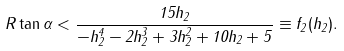<formula> <loc_0><loc_0><loc_500><loc_500>R \tan \alpha < \frac { 1 5 h _ { 2 } } { - h _ { 2 } ^ { 4 } - 2 h _ { 2 } ^ { 3 } + 3 h _ { 2 } ^ { 2 } + 1 0 h _ { 2 } + 5 } \equiv f _ { 2 } ( h _ { 2 } ) .</formula> 